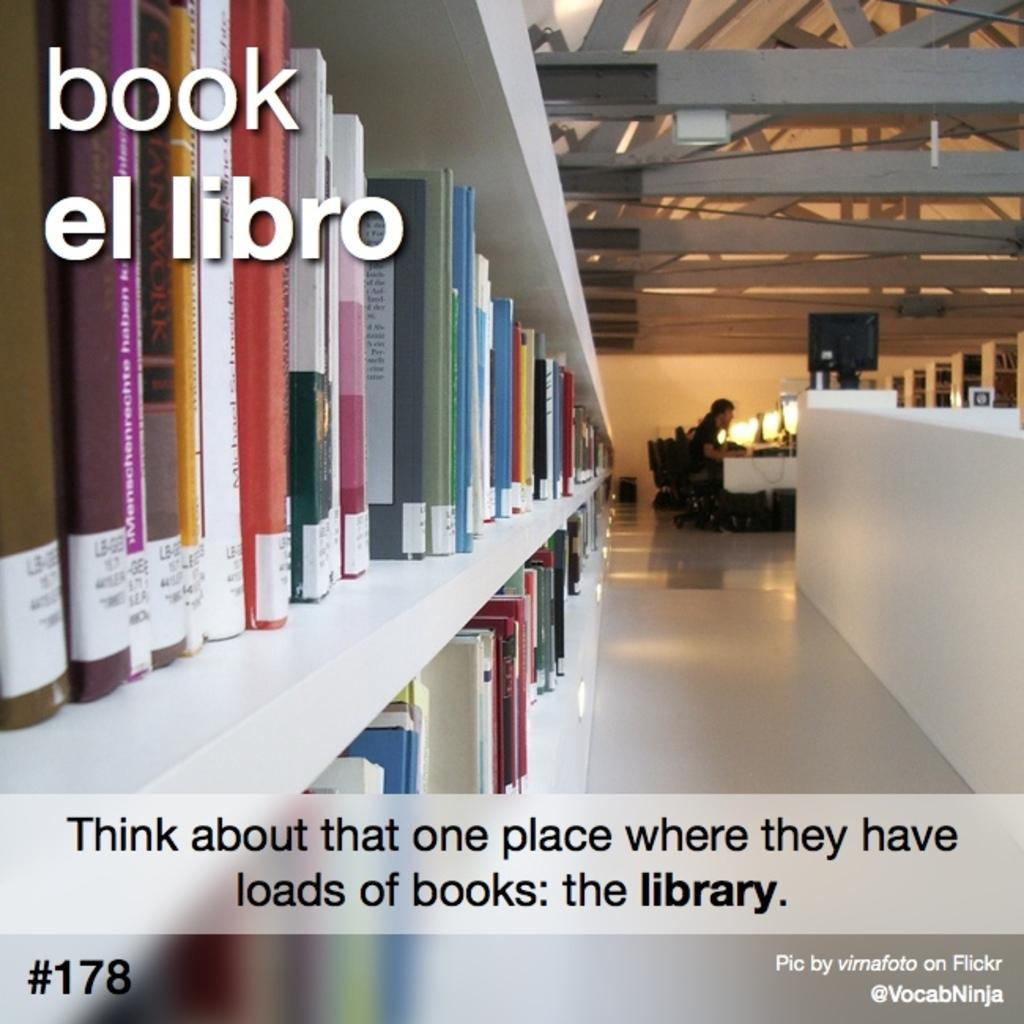<image>
Write a terse but informative summary of the picture. A library is shown with white shelves and the slogan book el libro. 